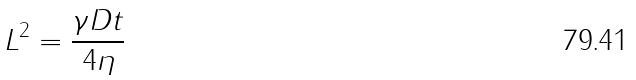<formula> <loc_0><loc_0><loc_500><loc_500>L ^ { 2 } = \frac { \gamma D t } { 4 \eta }</formula> 